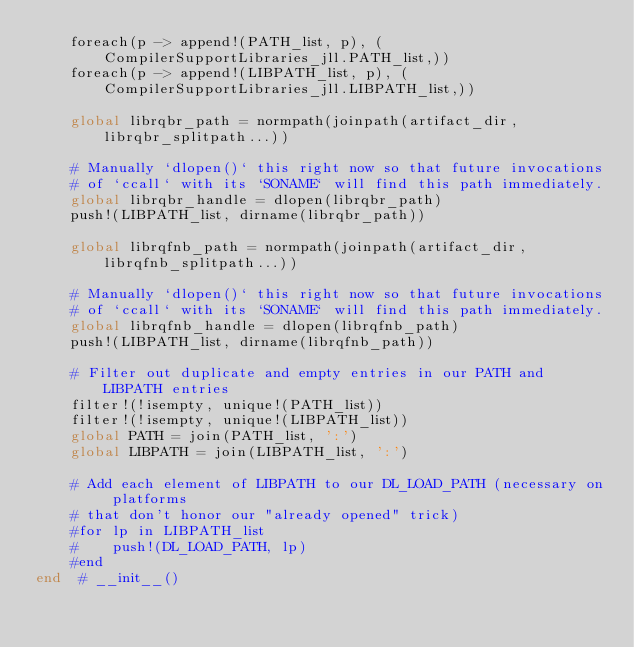<code> <loc_0><loc_0><loc_500><loc_500><_Julia_>    foreach(p -> append!(PATH_list, p), (CompilerSupportLibraries_jll.PATH_list,))
    foreach(p -> append!(LIBPATH_list, p), (CompilerSupportLibraries_jll.LIBPATH_list,))

    global librqbr_path = normpath(joinpath(artifact_dir, librqbr_splitpath...))

    # Manually `dlopen()` this right now so that future invocations
    # of `ccall` with its `SONAME` will find this path immediately.
    global librqbr_handle = dlopen(librqbr_path)
    push!(LIBPATH_list, dirname(librqbr_path))

    global librqfnb_path = normpath(joinpath(artifact_dir, librqfnb_splitpath...))

    # Manually `dlopen()` this right now so that future invocations
    # of `ccall` with its `SONAME` will find this path immediately.
    global librqfnb_handle = dlopen(librqfnb_path)
    push!(LIBPATH_list, dirname(librqfnb_path))

    # Filter out duplicate and empty entries in our PATH and LIBPATH entries
    filter!(!isempty, unique!(PATH_list))
    filter!(!isempty, unique!(LIBPATH_list))
    global PATH = join(PATH_list, ':')
    global LIBPATH = join(LIBPATH_list, ':')

    # Add each element of LIBPATH to our DL_LOAD_PATH (necessary on platforms
    # that don't honor our "already opened" trick)
    #for lp in LIBPATH_list
    #    push!(DL_LOAD_PATH, lp)
    #end
end  # __init__()

</code> 